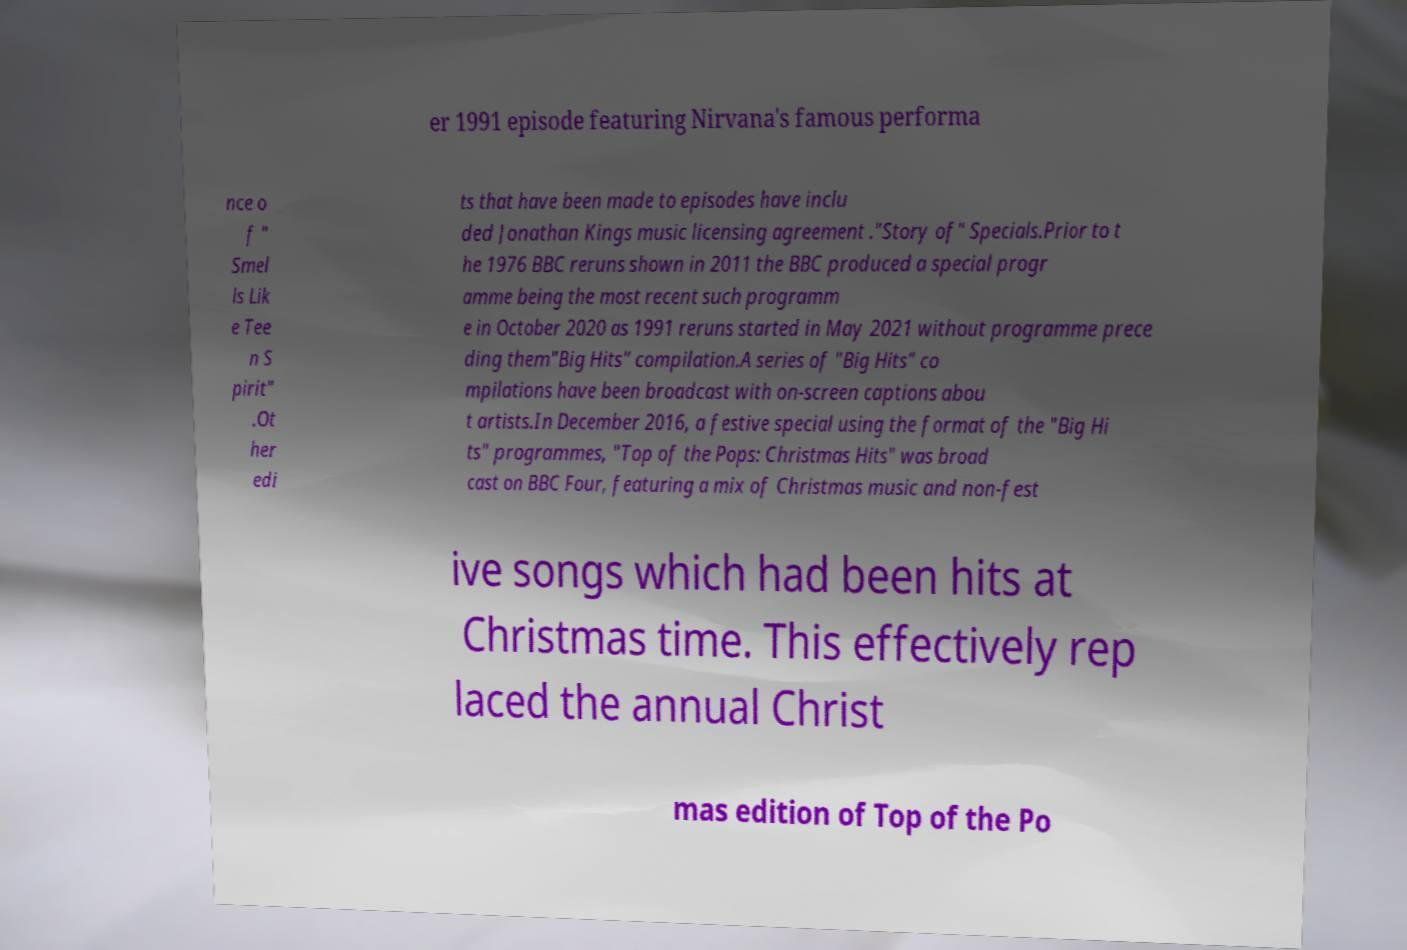Can you read and provide the text displayed in the image?This photo seems to have some interesting text. Can you extract and type it out for me? er 1991 episode featuring Nirvana's famous performa nce o f " Smel ls Lik e Tee n S pirit" .Ot her edi ts that have been made to episodes have inclu ded Jonathan Kings music licensing agreement ."Story of" Specials.Prior to t he 1976 BBC reruns shown in 2011 the BBC produced a special progr amme being the most recent such programm e in October 2020 as 1991 reruns started in May 2021 without programme prece ding them"Big Hits" compilation.A series of "Big Hits" co mpilations have been broadcast with on-screen captions abou t artists.In December 2016, a festive special using the format of the "Big Hi ts" programmes, "Top of the Pops: Christmas Hits" was broad cast on BBC Four, featuring a mix of Christmas music and non-fest ive songs which had been hits at Christmas time. This effectively rep laced the annual Christ mas edition of Top of the Po 